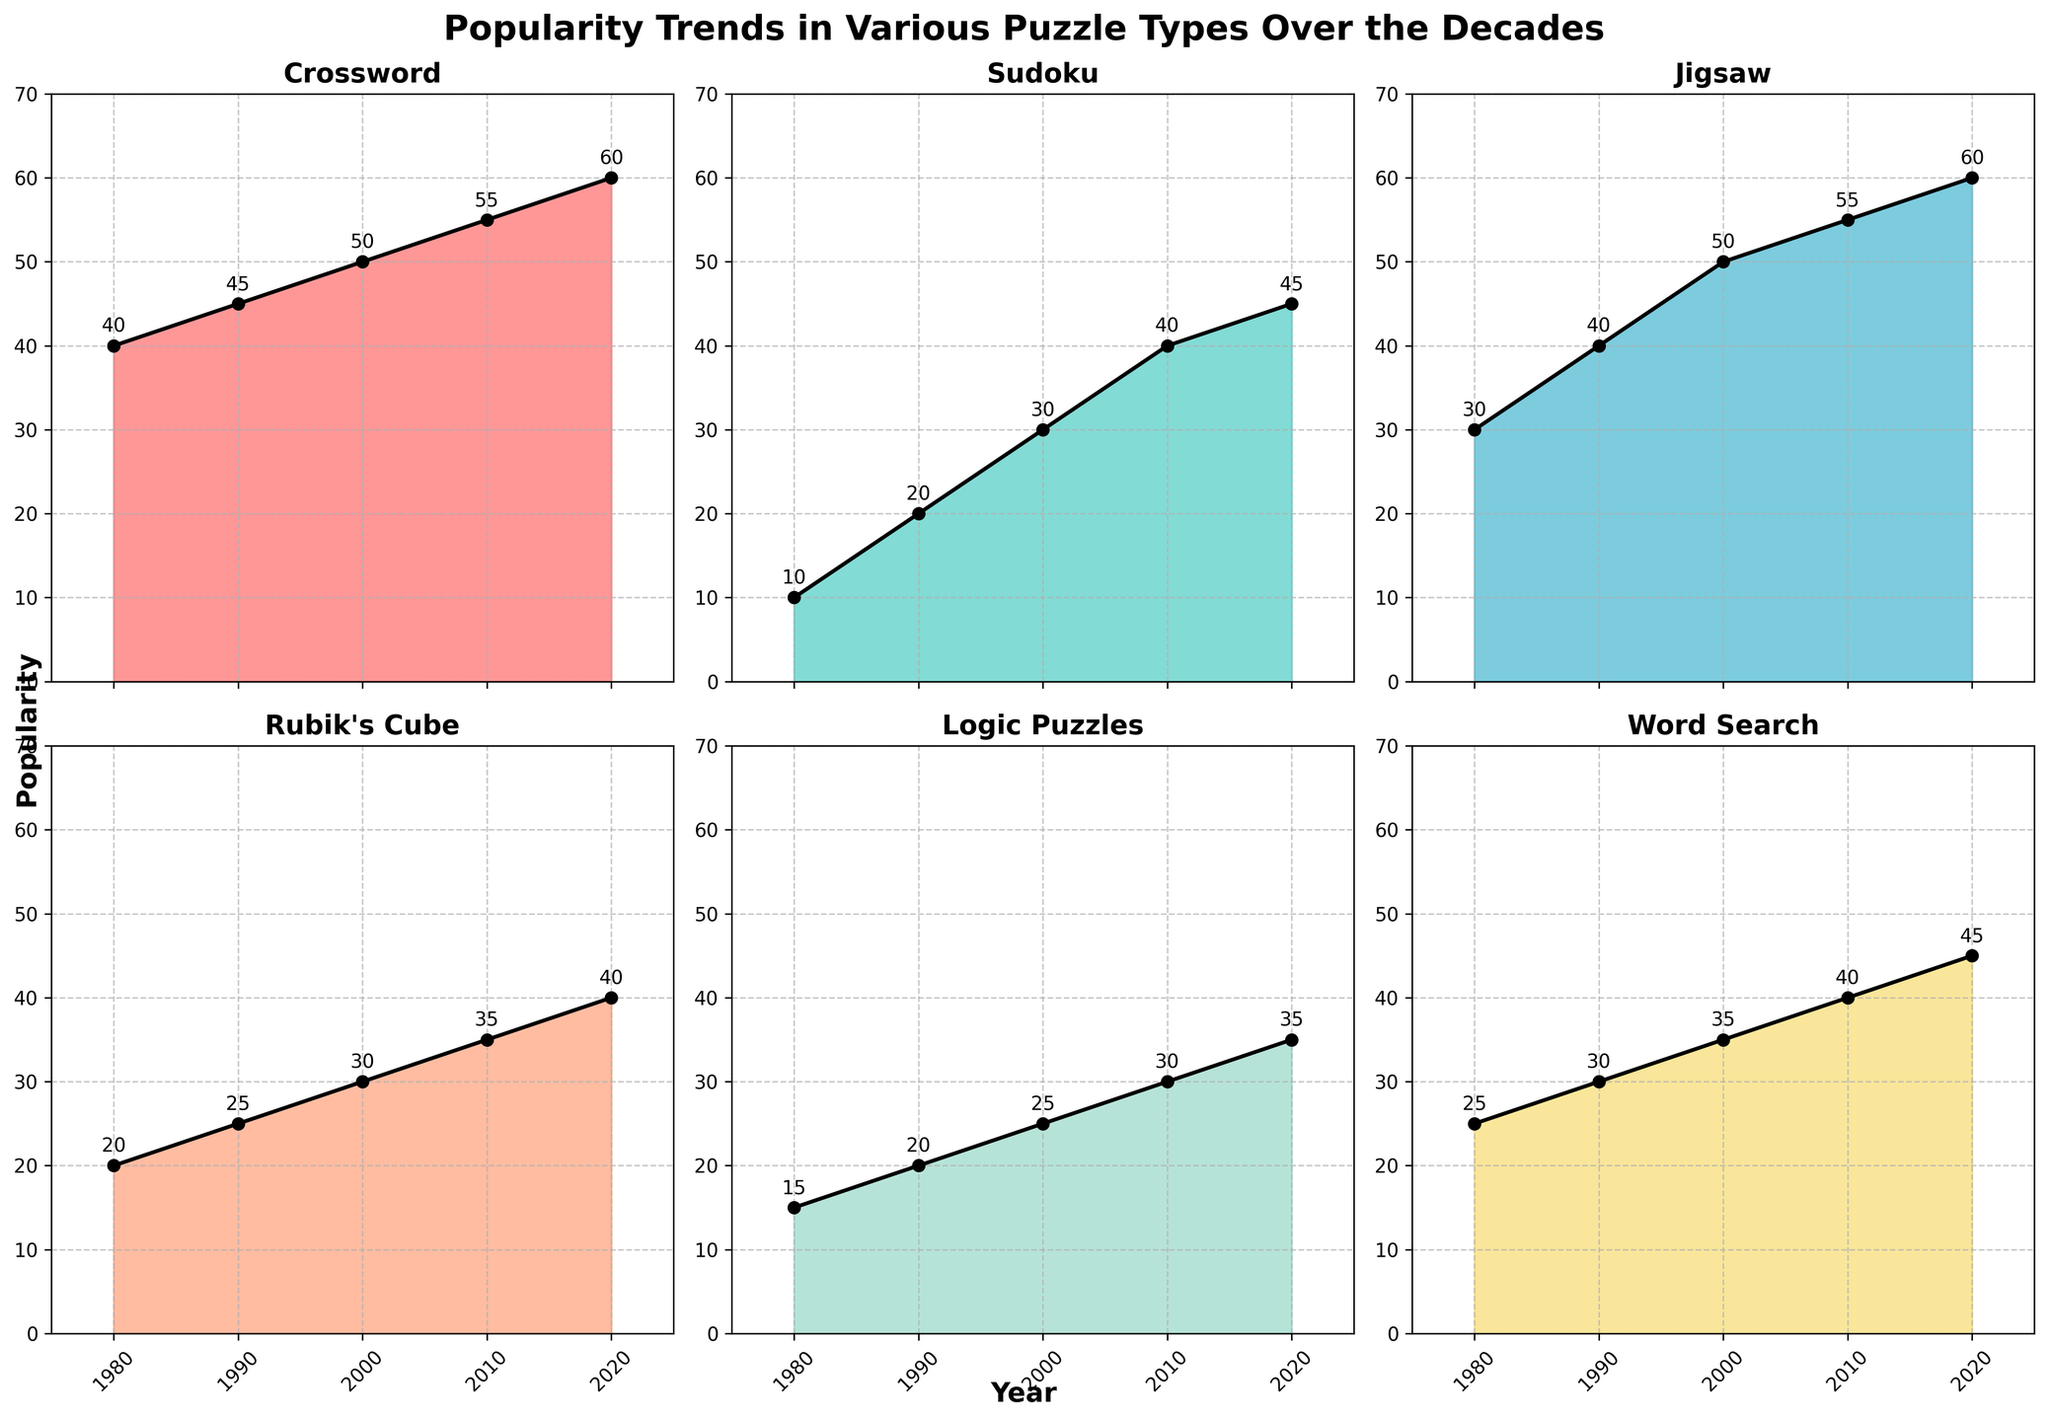What is the title of the figure? The main title of the figure is displayed above the entire subplot grid in large, bold text. Reading this title gives us the overall context of the figure, which is "Popularity Trends in Various Puzzle Types Over the Decades".
Answer: Popularity Trends in Various Puzzle Types Over the Decades What is the peak popularity of Sudoku and in which year did it occur? Examining the plot for Sudoku, we can see that the peak height of the area chart reaches 45. The annotation at this peak shows the popularity and the corresponding year, which is 2020.
Answer: 45, 2020 How many years are represented in the figure? Each subplot shares the same x-axis, which is labeled with the years. Counting these labels, we see the years 1980, 1990, 2000, 2010, and 2020, totaling 5 years.
Answer: 5 Which puzzle type experienced the greatest increase in popularity from 1980 to 2020? To determine this, we calculate the increase in popularity for each puzzle type between 1980 and 2020 by subtracting the 1980 value from the 2020 value. Crossword: 60-40=20, Sudoku: 45-10=35, Jigsaw: 60-30=30, Rubik's Cube: 40-20=20, Logic Puzzles: 35-15=20, Word Search: 45-25=20. Sudoku has the greatest increase of 35 points.
Answer: Sudoku Which two puzzle types showed an equal popularity trend in any given year, and what was that year and value? By examining the plots, we observe that both Ruby's Cube and Word Search show a popularity value of 25 in the year 1990. This is evident by the annotations at this data point in their respective subplots.
Answer: Rubik's Cube and Word Search, 1990, 25 What is the average popularity of Jigsaw puzzles over the given years? Summing the popularity values of Jigsaw puzzles over the years 1980, 1990, 2000, 2010, and 2020 gives us 30+40+50+55+60 = 235. Dividing this sum by the number of years (5) gives an average of 235/5, which is 47.
Answer: 47 Which puzzle type experienced the least change in popularity over the decades, and what is the difference between the highest and lowest popularity values for that puzzle type? Calculating the differences in popularity for each puzzle type:
Crossword: 60-40=20,
Sudoku: 45-10=35,
Jigsaw: 60-30=30,
Rubik's Cube: 40-20=20,
Logic Puzzles: 35-15=20,
Word Search: 45-25=20.
Crosswords, Rubik’s Cube, Logic Puzzles, and Word Search all have a 20-point difference, the smallest amount.
Answer: Crossword, Rubik's Cube, Logic Puzzles, Word Search, 20 Which puzzle type had the highest popularity in the year 2000? Looking at the annotations for each subplot corresponding to the year 2000, Jigsaw has the highest popularity with a value of 50, tied with Crossword.
Answer: Jigsaw and Crossword 